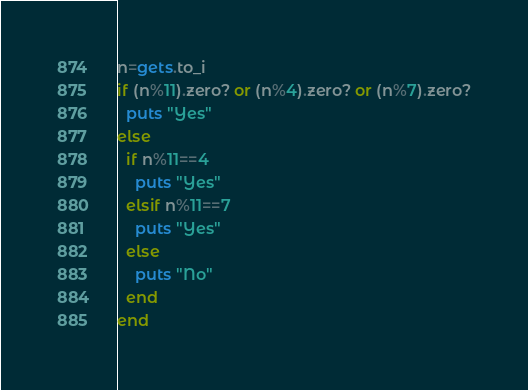Convert code to text. <code><loc_0><loc_0><loc_500><loc_500><_Ruby_>n=gets.to_i
if (n%11).zero? or (n%4).zero? or (n%7).zero?
  puts "Yes"
else
  if n%11==4
    puts "Yes"
  elsif n%11==7
    puts "Yes"
  else
    puts "No"
  end
end
</code> 